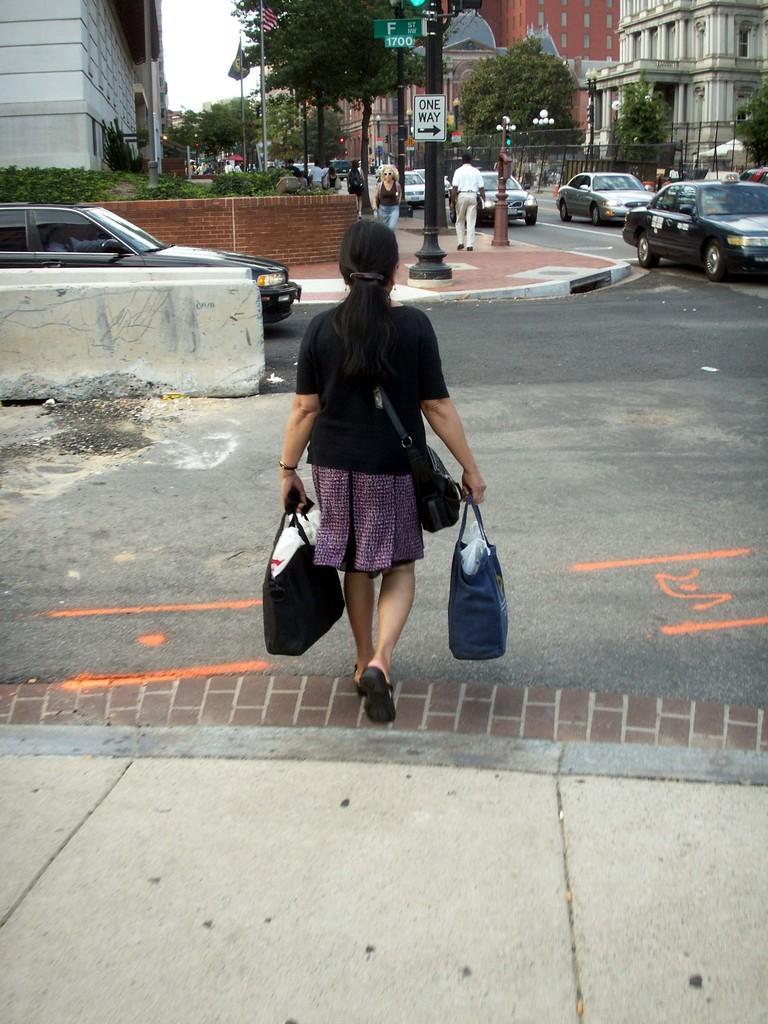Could you give a brief overview of what you see in this image? In this picture we can see a woman is walking and she is holding the bags. In front of the woman, there is a pole with boards attached to it. On the right side of the pole, there are vehicles on the road. On the left side of the people, there is a wall, flag and plants. At the top right side of the image, there are buildings, trees, fencing and the poles. 